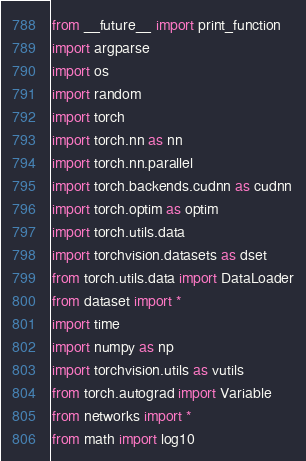<code> <loc_0><loc_0><loc_500><loc_500><_Python_>from __future__ import print_function
import argparse
import os
import random
import torch
import torch.nn as nn
import torch.nn.parallel
import torch.backends.cudnn as cudnn
import torch.optim as optim
import torch.utils.data
import torchvision.datasets as dset
from torch.utils.data import DataLoader
from dataset import *
import time
import numpy as np
import torchvision.utils as vutils
from torch.autograd import Variable
from networks import *
from math import log10</code> 